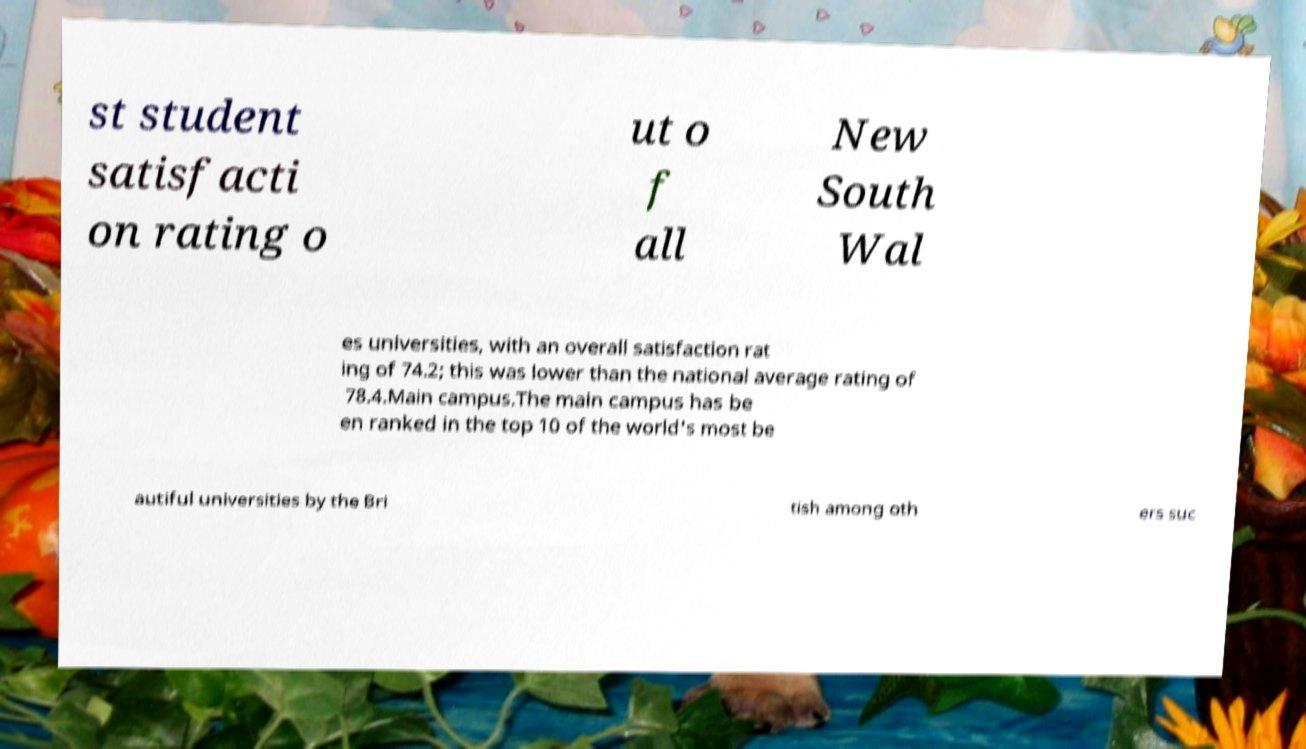What messages or text are displayed in this image? I need them in a readable, typed format. st student satisfacti on rating o ut o f all New South Wal es universities, with an overall satisfaction rat ing of 74.2; this was lower than the national average rating of 78.4.Main campus.The main campus has be en ranked in the top 10 of the world's most be autiful universities by the Bri tish among oth ers suc 